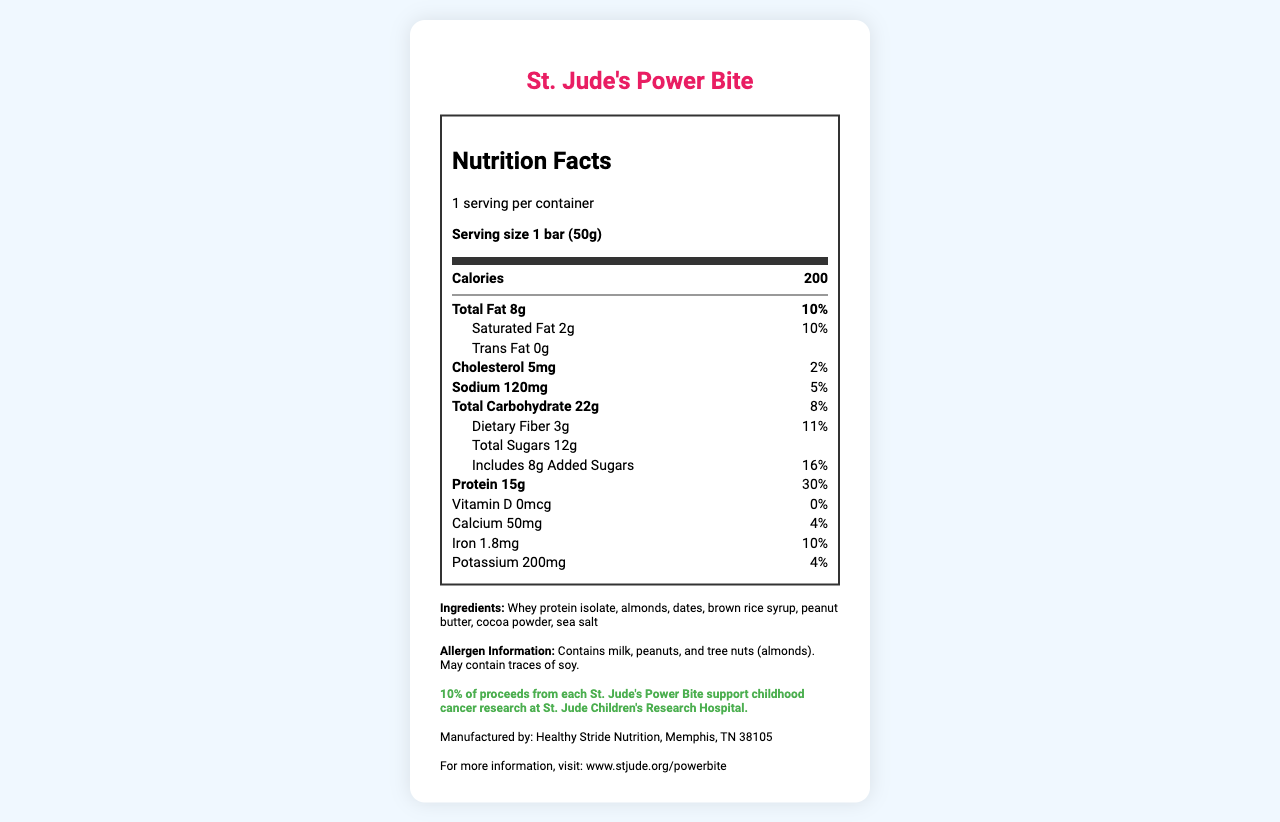what is the serving size of St. Jude's Power Bite? The document specifies that the serving size of St. Jude's Power Bite is 1 bar (50g).
Answer: 1 bar (50g) how many calories are in one serving of St. Jude's Power Bite? The document states that one serving of St. Jude's Power Bite contains 200 calories.
Answer: 200 what percentage of the daily value of protein does one serving provide? The document indicates that one serving provides 30% of the daily value of protein.
Answer: 30% what are the main ingredients in St. Jude's Power Bite? The ingredients listed are whey protein isolate, almonds, dates, brown rice syrup, peanut butter, cocoa powder, and sea salt.
Answer: Whey protein isolate, almonds, dates, brown rice syrup, peanut butter, cocoa powder, sea salt does St. Jude's Power Bite contain any trans fat? The document states that St. Jude's Power Bite contains 0g of trans fat.
Answer: No which mineral has the highest daily value percentage in St. Jude's Power Bite? A. Calcium B. Iron C. Potassium D. Sodium The document shows that iron has a daily value percentage of 10%, which is higher than the percentages of calcium (4%), potassium (4%), and sodium (5%).
Answer: B. Iron how much sodium does one serving of St. Jude's Power Bite contain? A. 50mg B. 120mg C. 200mg D. 500mg The document specifies that one serving contains 120mg of sodium.
Answer: B. 120mg is St. Jude's Power Bite free from allergens? The document notes that the product contains milk, peanuts, and tree nuts (almonds) and may contain traces of soy.
Answer: No does St. Jude's Power Bite include added sugars? The document specifies that St. Jude's Power Bite includes 8g of added sugars.
Answer: Yes can you determine the exact macronutrient breakdown (percentages) of each component (protein, carbs, fats) by weight? The document provides information on the amounts of these macronutrients but does not provide enough information to determine their exact breakdown by percentages of the total weight.
Answer: Cannot be determined how does the purchase of St. Jude’s Power Bite support charity? The document states that 10% of the proceeds from each purchase go toward supporting childhood cancer research at St. Jude Children's Research Hospital.
Answer: 10% of proceeds from each St. Jude's Power Bite support childhood cancer research at St. Jude Children's Research Hospital. explain the main purpose of this document The document provides detailed nutrition facts, lists the ingredients and allergen information, highlights how proceeds from the product support charity, and includes contact information for further inquiries.
Answer: To inform consumers about the nutritional content, ingredients, allergen information, and charitable contribution details of St. Jude's Power Bite. what is the manufacturer's name and location? The document states that St. Jude's Power Bite is manufactured by Healthy Stride Nutrition in Memphis, TN 38105.
Answer: Healthy Stride Nutrition, Memphis, TN 38105 